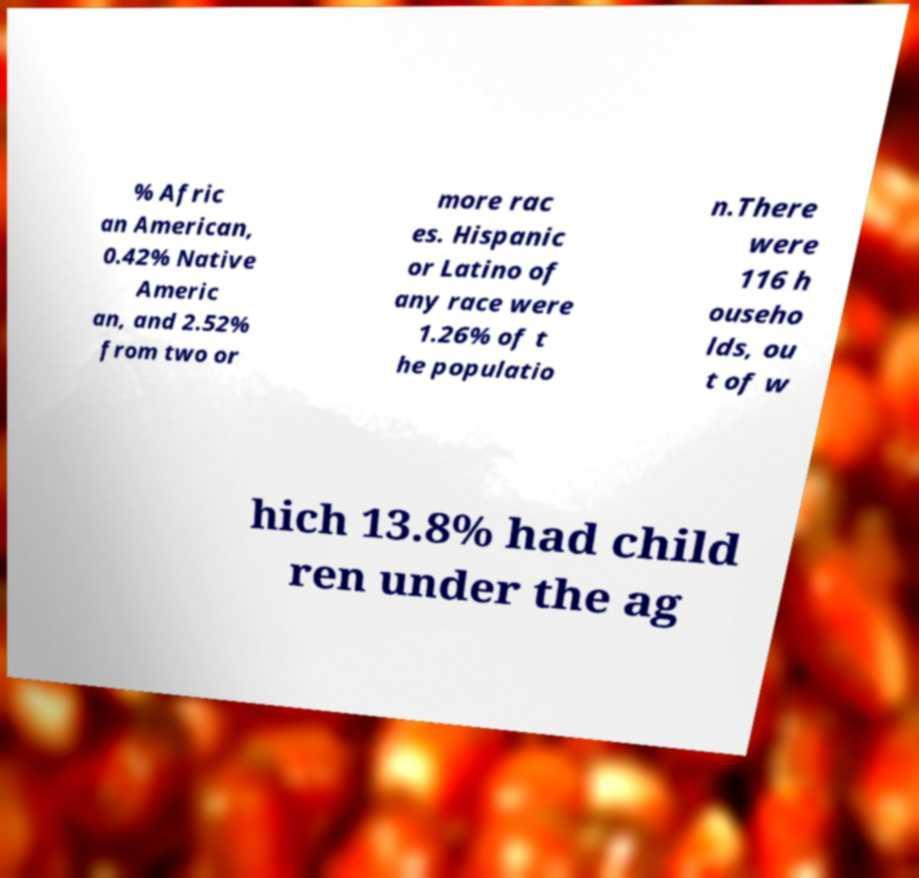I need the written content from this picture converted into text. Can you do that? % Afric an American, 0.42% Native Americ an, and 2.52% from two or more rac es. Hispanic or Latino of any race were 1.26% of t he populatio n.There were 116 h ouseho lds, ou t of w hich 13.8% had child ren under the ag 